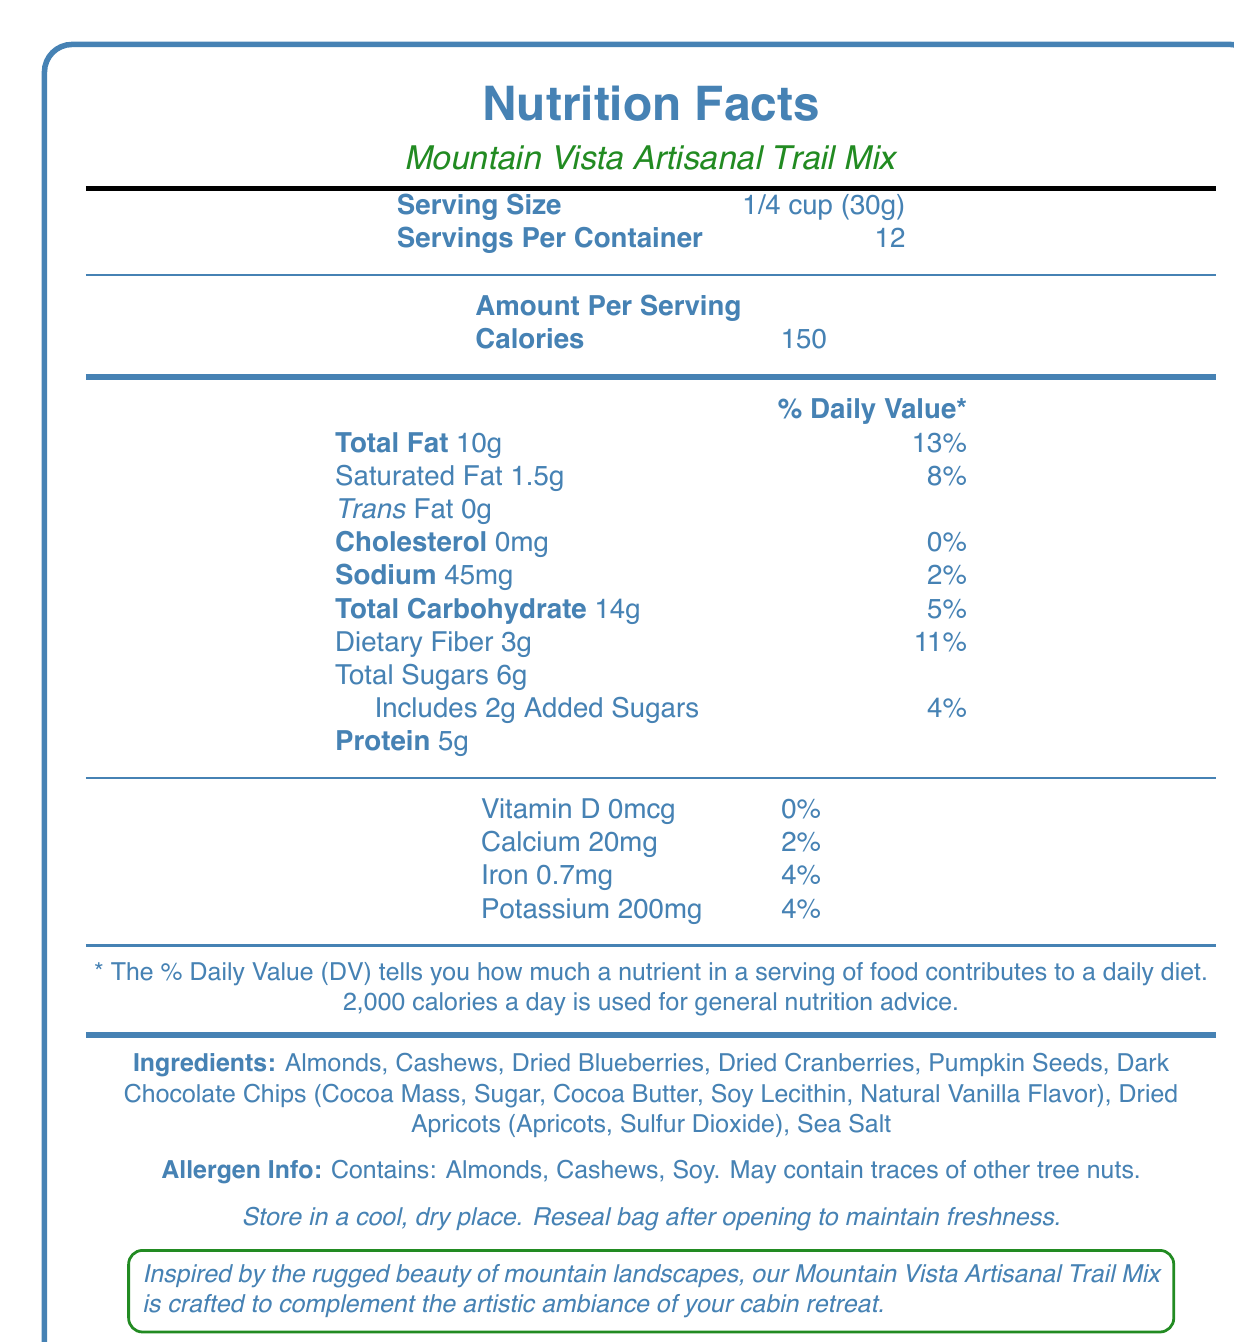what is the serving size of Mountain Vista Artisanal Trail Mix? The serving size is listed as "1/4 cup (30g)" in the Nutrition Facts section.
Answer: 1/4 cup (30g) how many servings are there per container? There are 12 servings per container, as indicated in the Nutrition Facts section.
Answer: 12 how many calories are there per serving? The document lists "Calories: 150" per serving.
Answer: 150 what is the amount of total fat in one serving? The Nutrition Facts section states "Total Fat: 10g".
Answer: 10g how much dietary fiber is there in one serving? The dietary fiber content per serving is stated as "3g" in the Nutrition Facts section.
Answer: 3g which of the following is NOT an ingredient in Mountain Vista Artisanal Trail Mix? A. Almonds B. Dried Blueberries C. Walnuts D. Sea Salt The ingredients listed are Almonds, Cashews, Dried Blueberries, Dried Cranberries, Pumpkin Seeds, Dark Chocolate Chips, Dried Apricots, and Sea Salt. Walnuts are not listed.
Answer: C what percentage of the daily value of sodium does one serving provide? A. 1% B. 2% C. 3% D. 4% The Nutrition Facts section indicates that one serving provides "2%" of the daily value of sodium.
Answer: B does this product contain any soy? The allergen information states that this product "Contains: Almonds, Cashews, Soy."
Answer: Yes what is the main idea of the document? The main idea is to provide detailed nutritional information, ingredients, allergen information, and the product's unique selling points such as sustainability and flavor profile.
Answer: The document presents the Nutrition Facts and related information for Mountain Vista Artisanal Trail Mix, a gourmet product designed to complement the artistic ambiance of a mountain cabin retreat. what is the daily value percentage of protein provided in one serving? The document lists the amount of protein as 5g but does not provide the daily value percentage.
Answer: Not listed what is the flavor profile of the trail mix? The flavor profile is described towards the end of the document.
Answer: A harmonious blend of sweet, salty, and nutty flavors with a rich, dark chocolate finish 